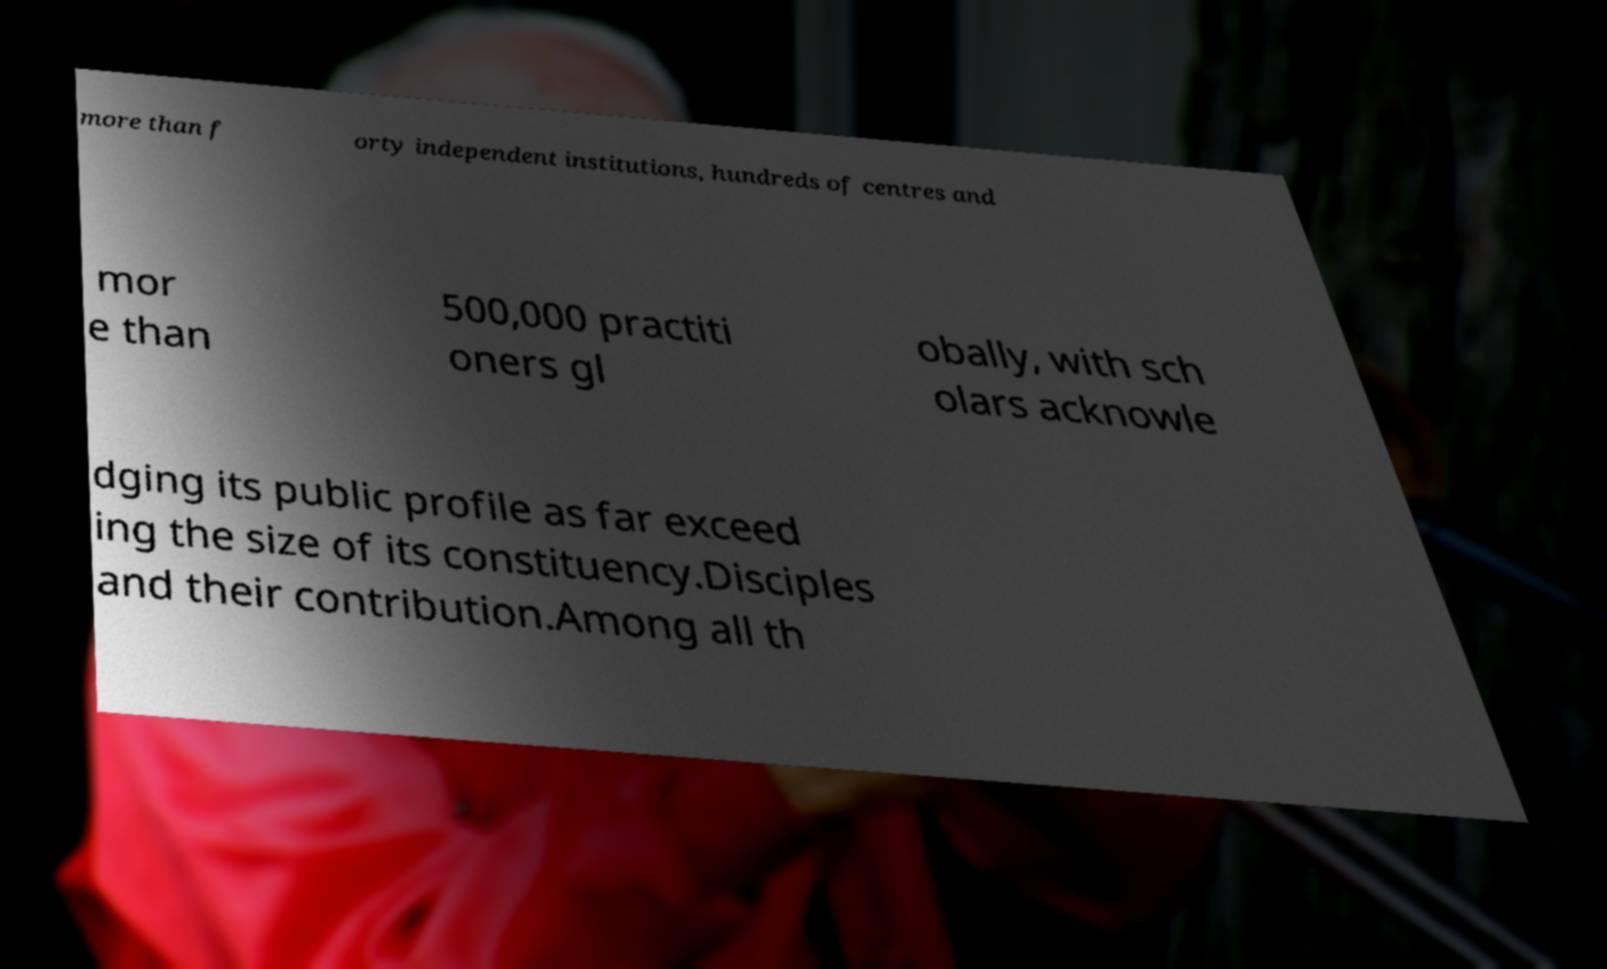There's text embedded in this image that I need extracted. Can you transcribe it verbatim? more than f orty independent institutions, hundreds of centres and mor e than 500,000 practiti oners gl obally, with sch olars acknowle dging its public profile as far exceed ing the size of its constituency.Disciples and their contribution.Among all th 